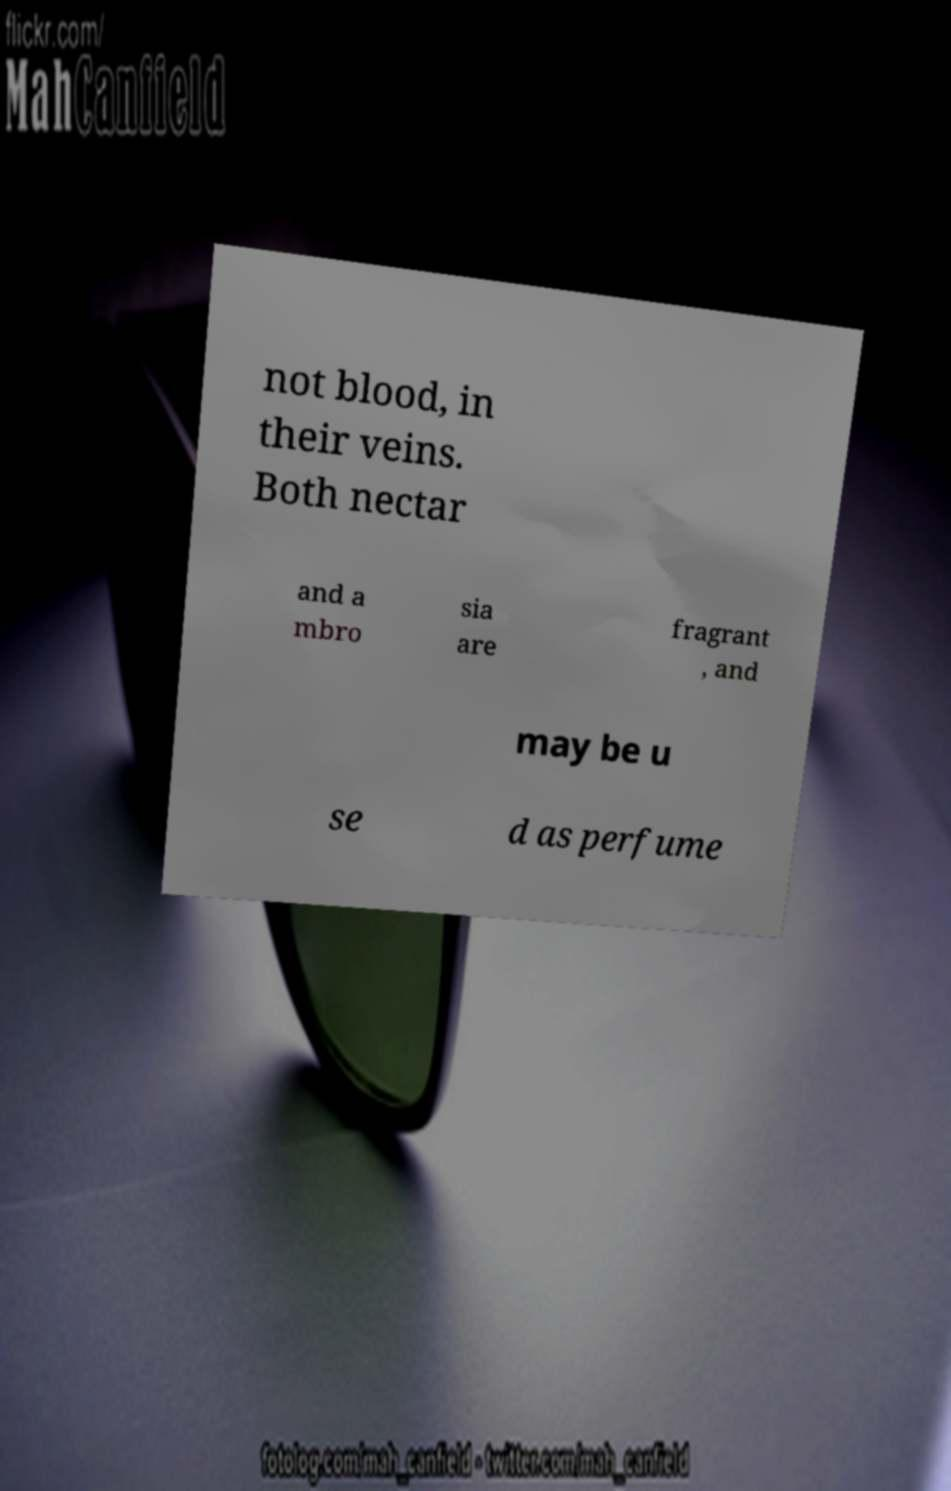Can you read and provide the text displayed in the image?This photo seems to have some interesting text. Can you extract and type it out for me? not blood, in their veins. Both nectar and a mbro sia are fragrant , and may be u se d as perfume 